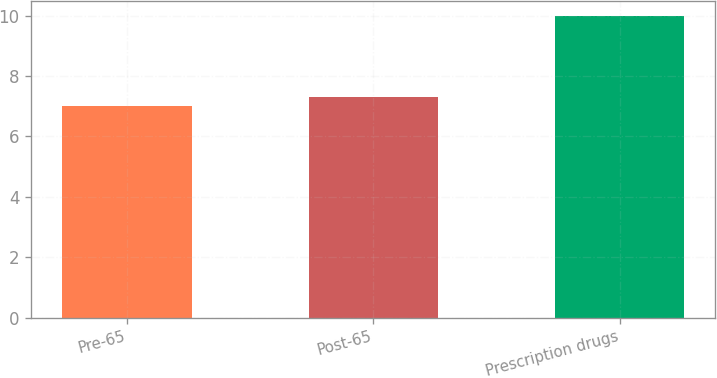Convert chart. <chart><loc_0><loc_0><loc_500><loc_500><bar_chart><fcel>Pre-65<fcel>Post-65<fcel>Prescription drugs<nl><fcel>7<fcel>7.3<fcel>10<nl></chart> 